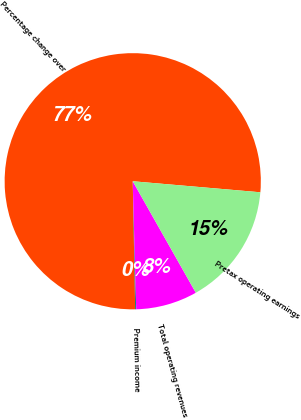Convert chart to OTSL. <chart><loc_0><loc_0><loc_500><loc_500><pie_chart><fcel>Percentage change over<fcel>Premium income<fcel>Total operating revenues<fcel>Pretax operating earnings<nl><fcel>76.68%<fcel>0.12%<fcel>7.77%<fcel>15.43%<nl></chart> 